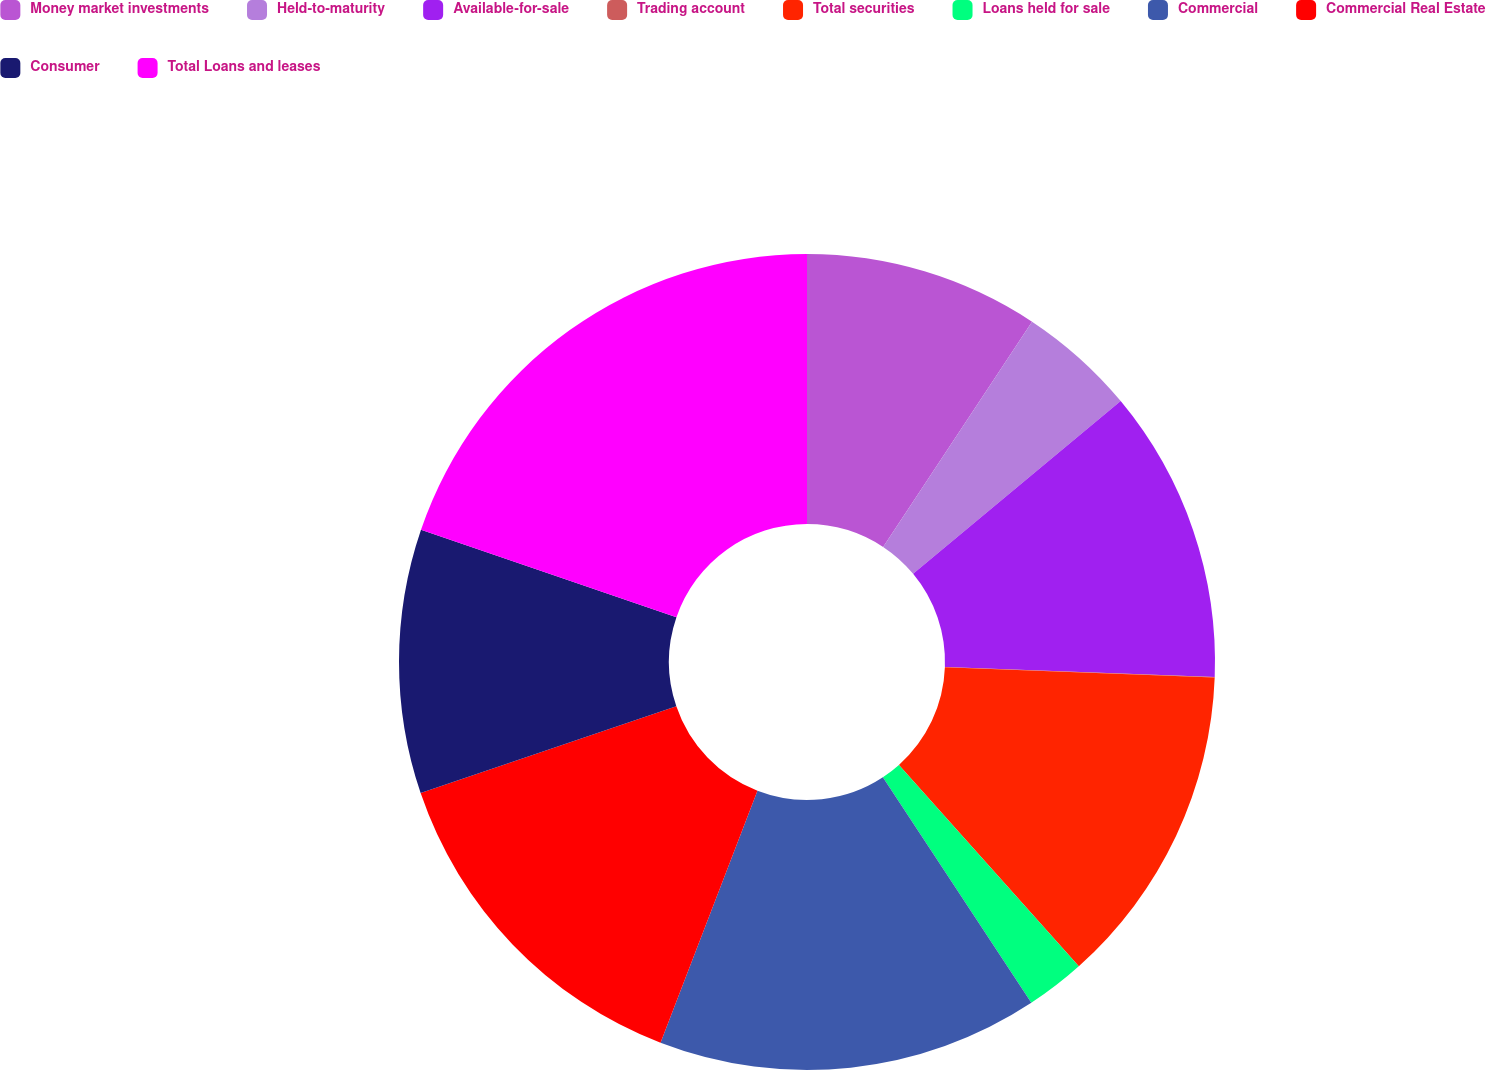<chart> <loc_0><loc_0><loc_500><loc_500><pie_chart><fcel>Money market investments<fcel>Held-to-maturity<fcel>Available-for-sale<fcel>Trading account<fcel>Total securities<fcel>Loans held for sale<fcel>Commercial<fcel>Commercial Real Estate<fcel>Consumer<fcel>Total Loans and leases<nl><fcel>9.3%<fcel>4.66%<fcel>11.63%<fcel>0.02%<fcel>12.79%<fcel>2.34%<fcel>15.11%<fcel>13.95%<fcel>10.46%<fcel>19.75%<nl></chart> 